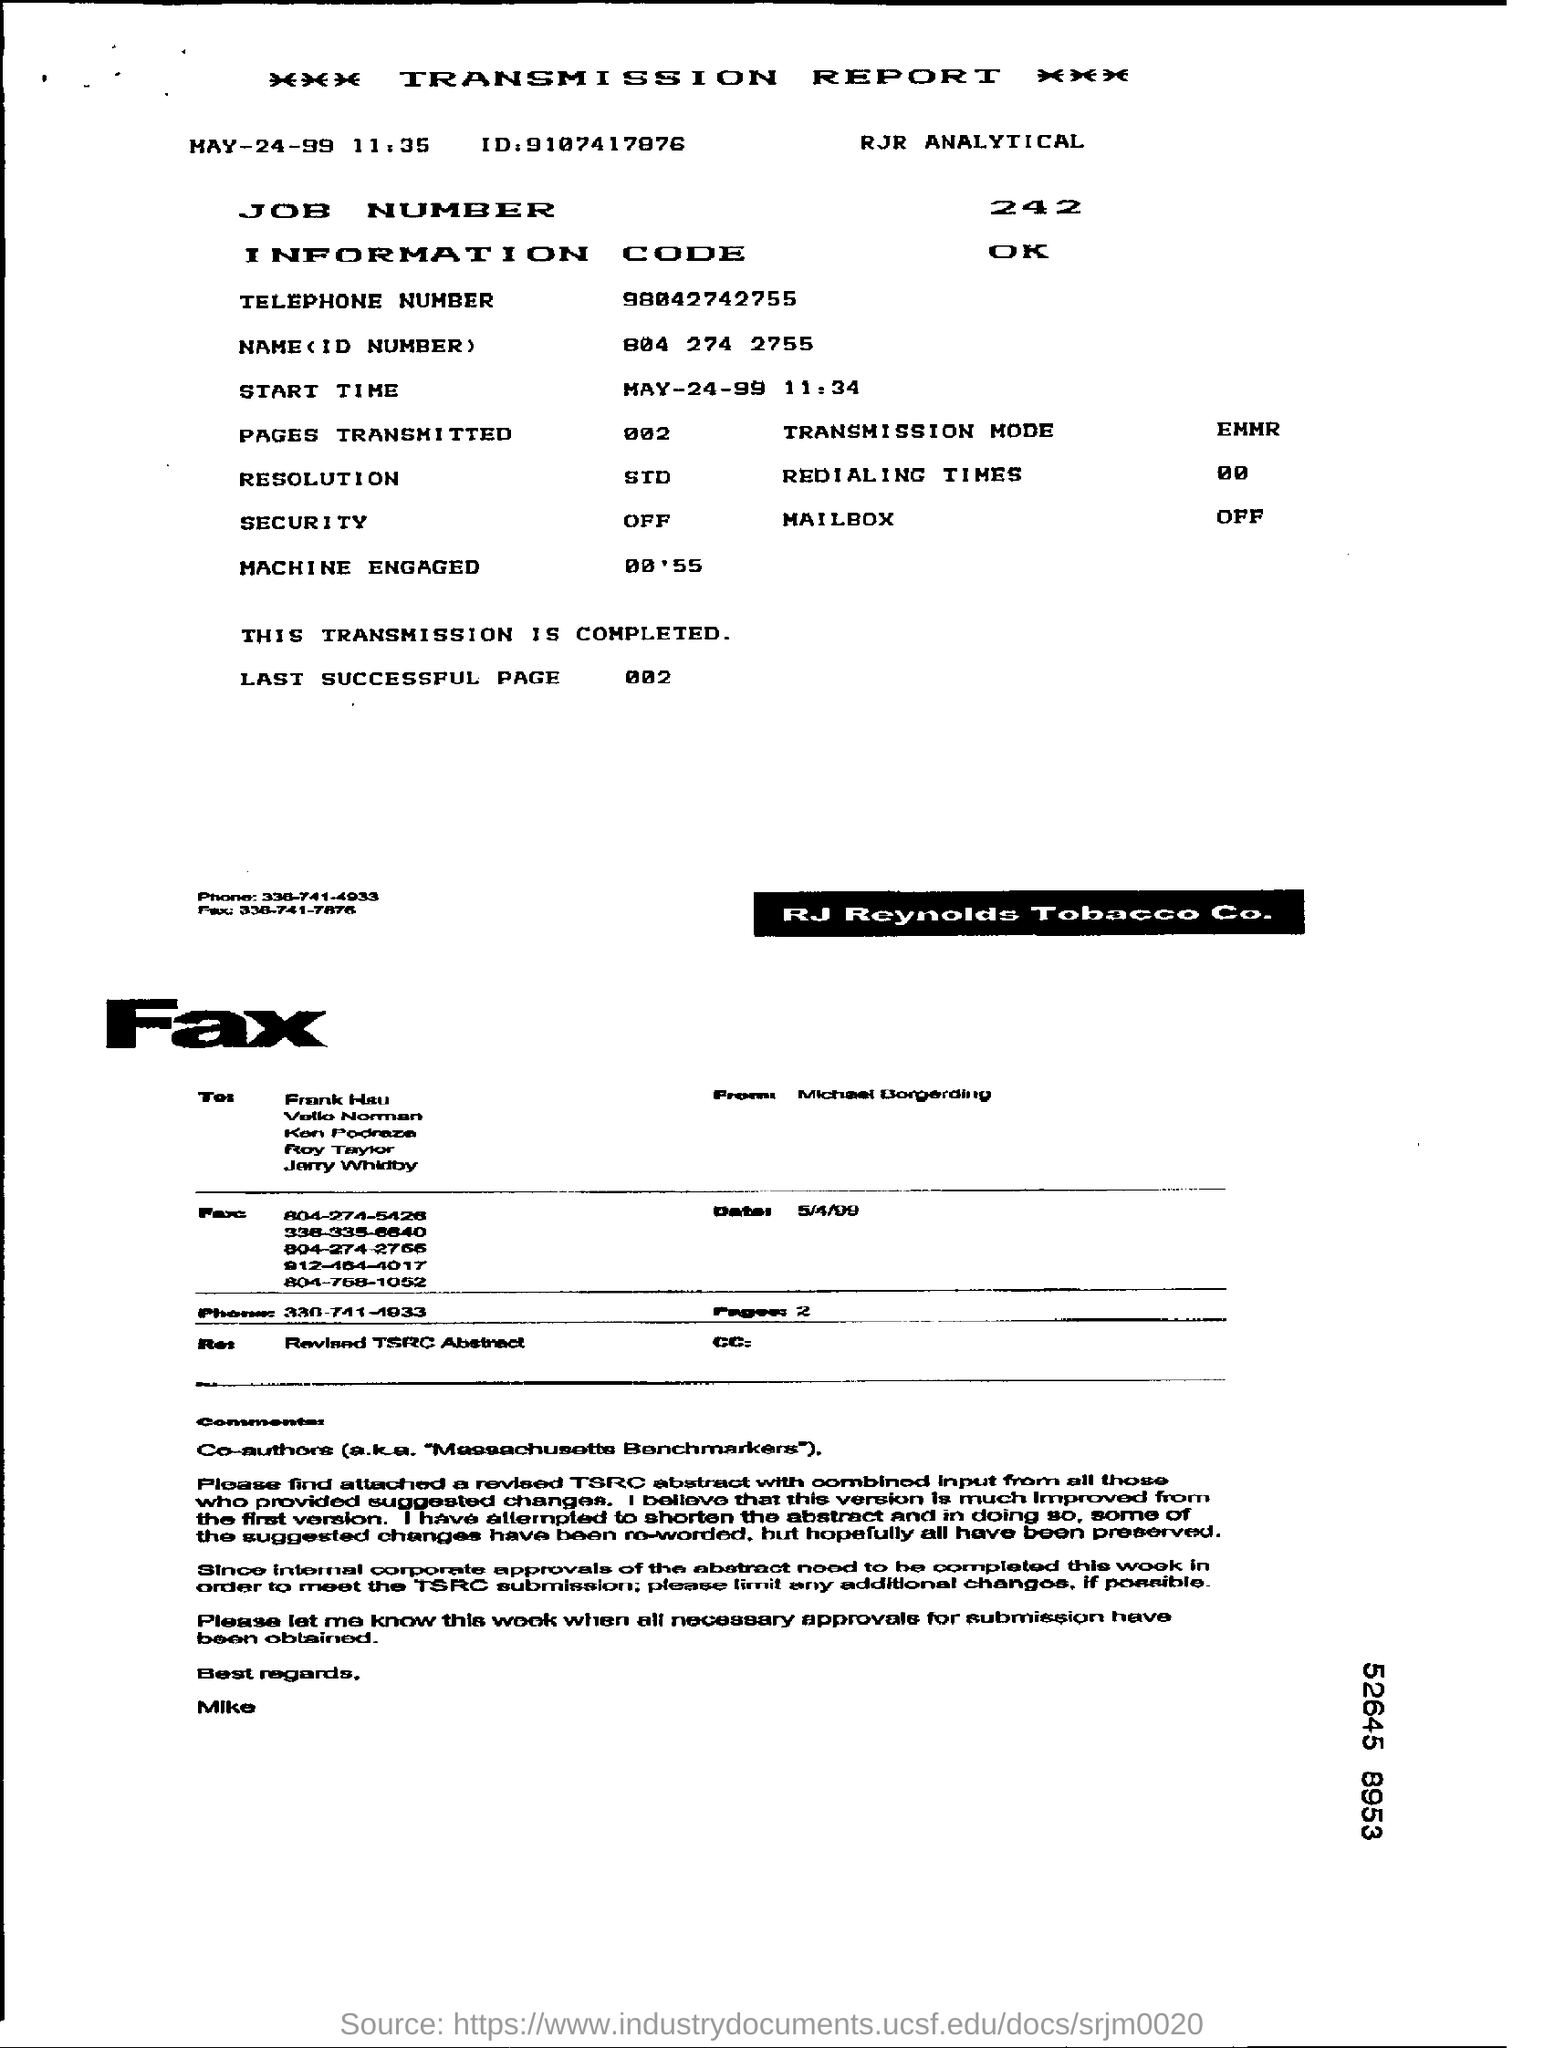Indicate a few pertinent items in this graphic. The status of security is currently off. The last successful page viewed was 002. The job number given in the transmission report is 242. 